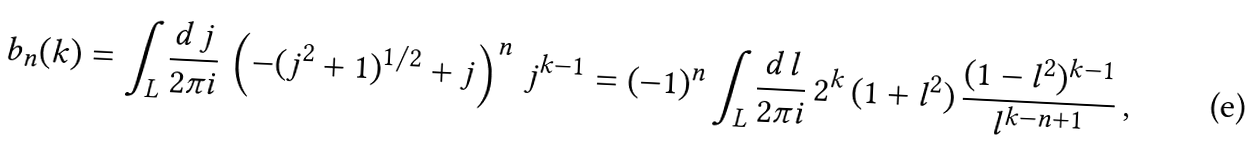<formula> <loc_0><loc_0><loc_500><loc_500>b _ { n } ( k ) = \int _ { L } \frac { d \, j } { 2 \pi i } \, \left ( - ( j ^ { 2 } + 1 ) ^ { 1 / 2 } + j \right ) ^ { n } \, j ^ { k - 1 } = ( - 1 ) ^ { n } \int _ { L } \frac { d \, l } { 2 \pi i } \, 2 ^ { k } \, ( 1 + l ^ { 2 } ) \, \frac { ( 1 - l ^ { 2 } ) ^ { k - 1 } } { l ^ { k - n + 1 } } \, ,</formula> 